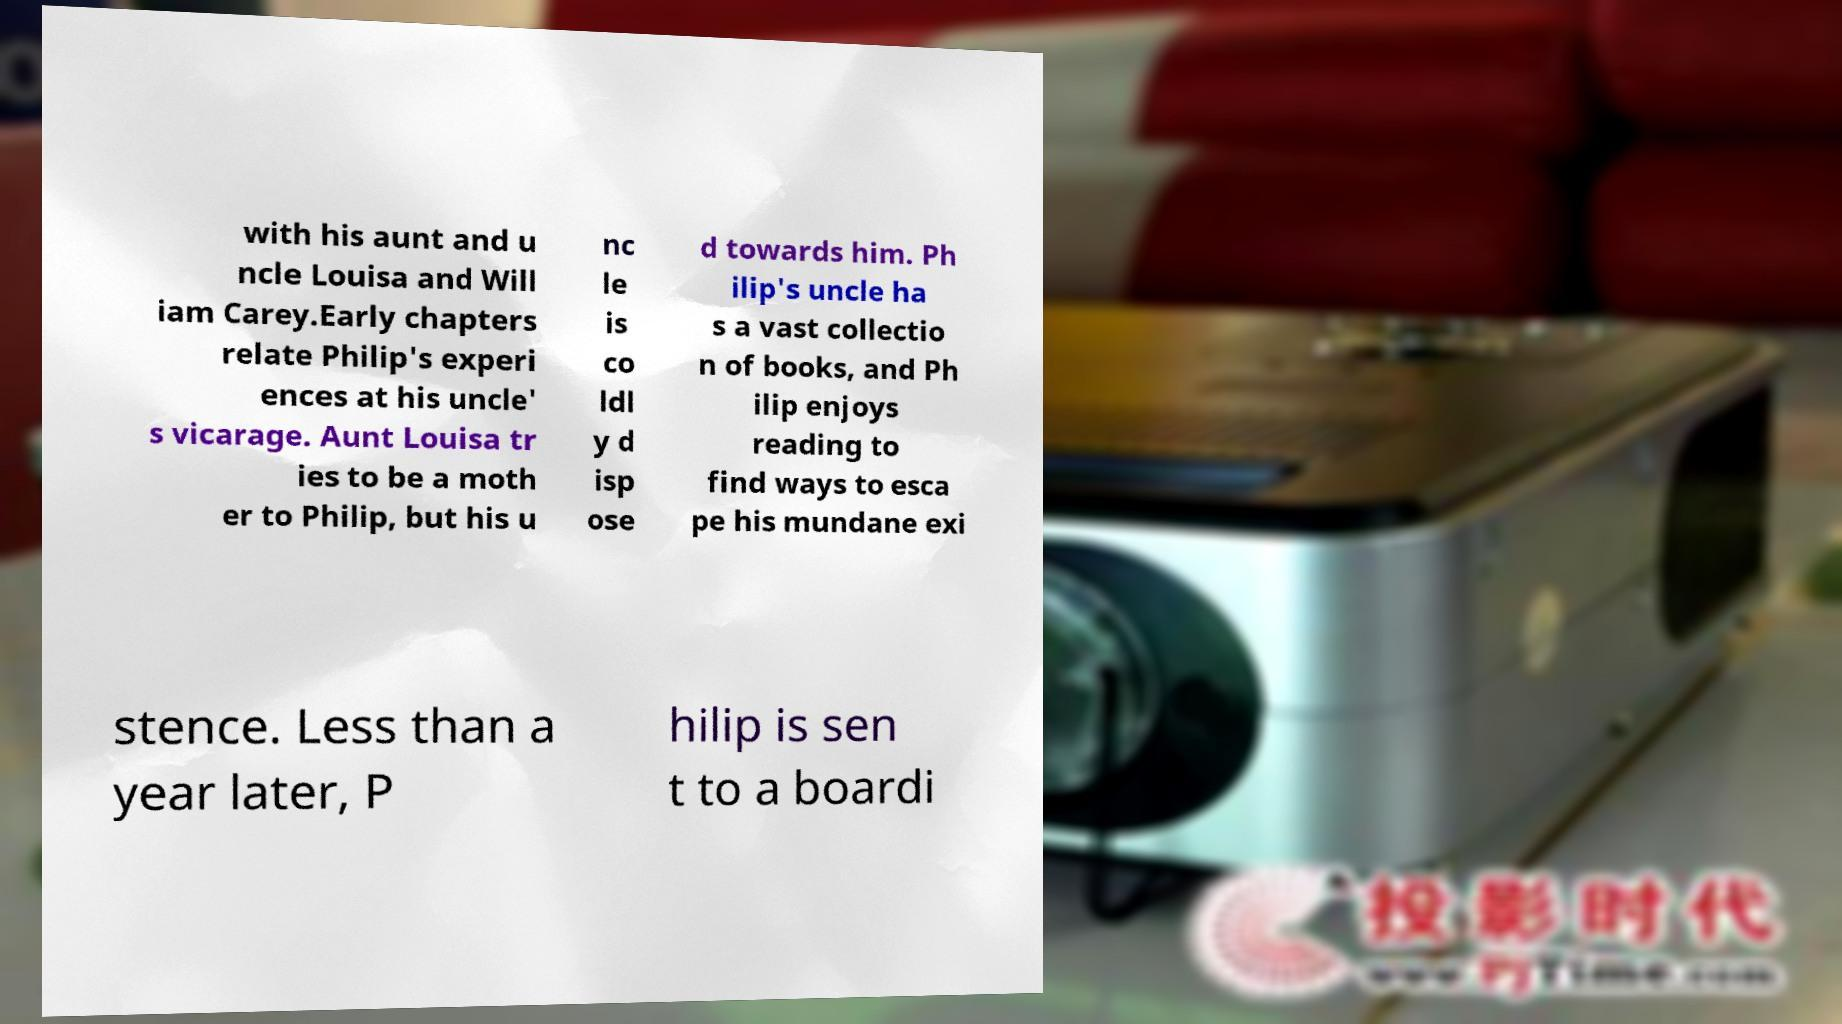I need the written content from this picture converted into text. Can you do that? with his aunt and u ncle Louisa and Will iam Carey.Early chapters relate Philip's experi ences at his uncle' s vicarage. Aunt Louisa tr ies to be a moth er to Philip, but his u nc le is co ldl y d isp ose d towards him. Ph ilip's uncle ha s a vast collectio n of books, and Ph ilip enjoys reading to find ways to esca pe his mundane exi stence. Less than a year later, P hilip is sen t to a boardi 